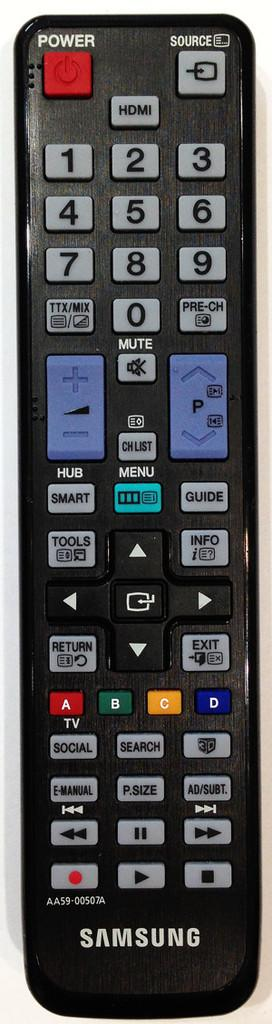<image>
Give a short and clear explanation of the subsequent image. Samsung TV Remote Control used for changing channels. 